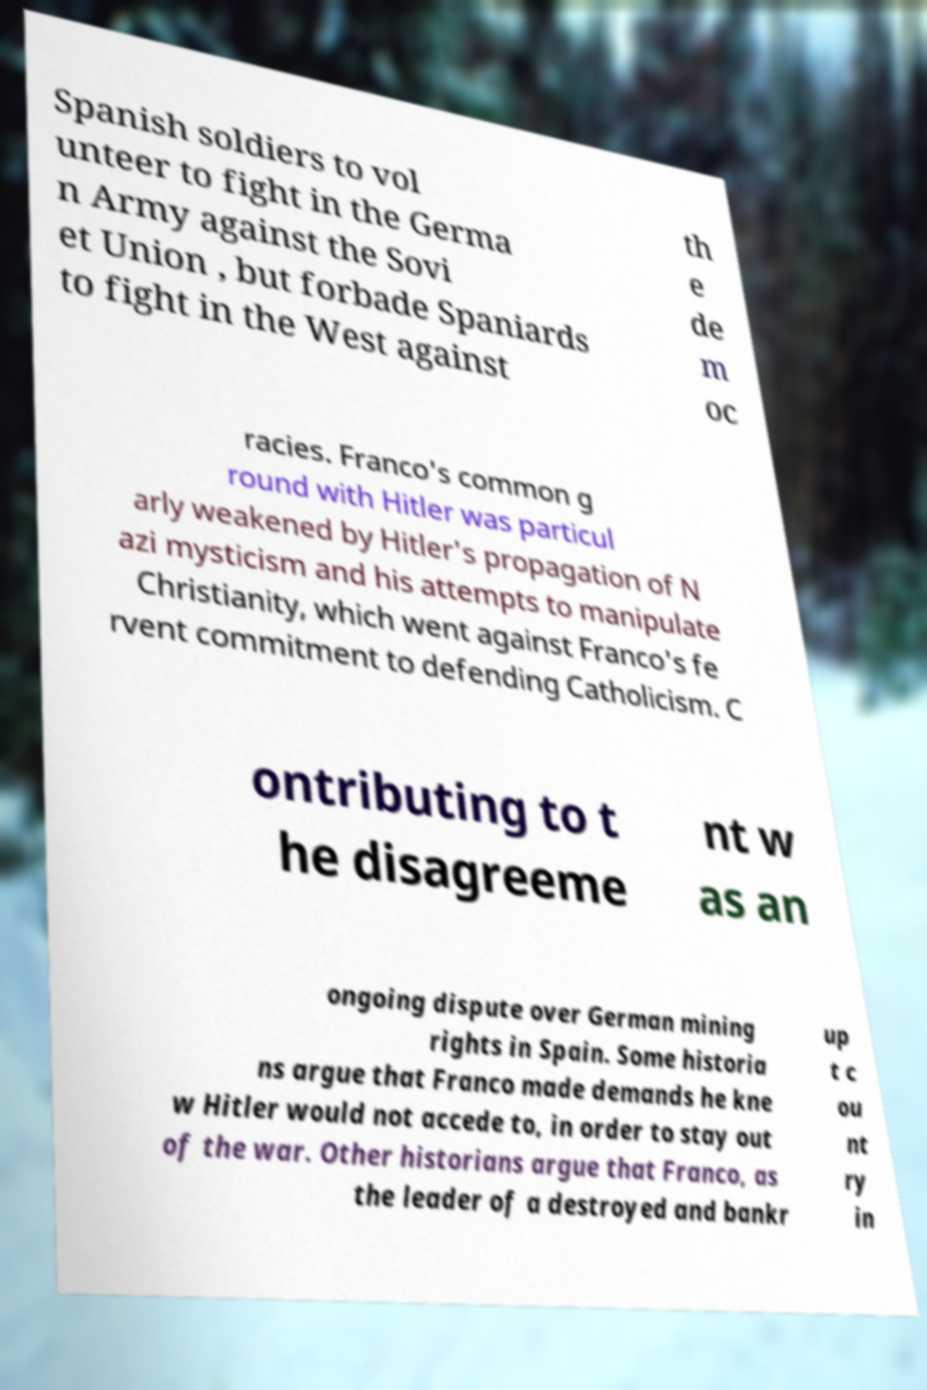Can you read and provide the text displayed in the image?This photo seems to have some interesting text. Can you extract and type it out for me? Spanish soldiers to vol unteer to fight in the Germa n Army against the Sovi et Union , but forbade Spaniards to fight in the West against th e de m oc racies. Franco's common g round with Hitler was particul arly weakened by Hitler's propagation of N azi mysticism and his attempts to manipulate Christianity, which went against Franco's fe rvent commitment to defending Catholicism. C ontributing to t he disagreeme nt w as an ongoing dispute over German mining rights in Spain. Some historia ns argue that Franco made demands he kne w Hitler would not accede to, in order to stay out of the war. Other historians argue that Franco, as the leader of a destroyed and bankr up t c ou nt ry in 